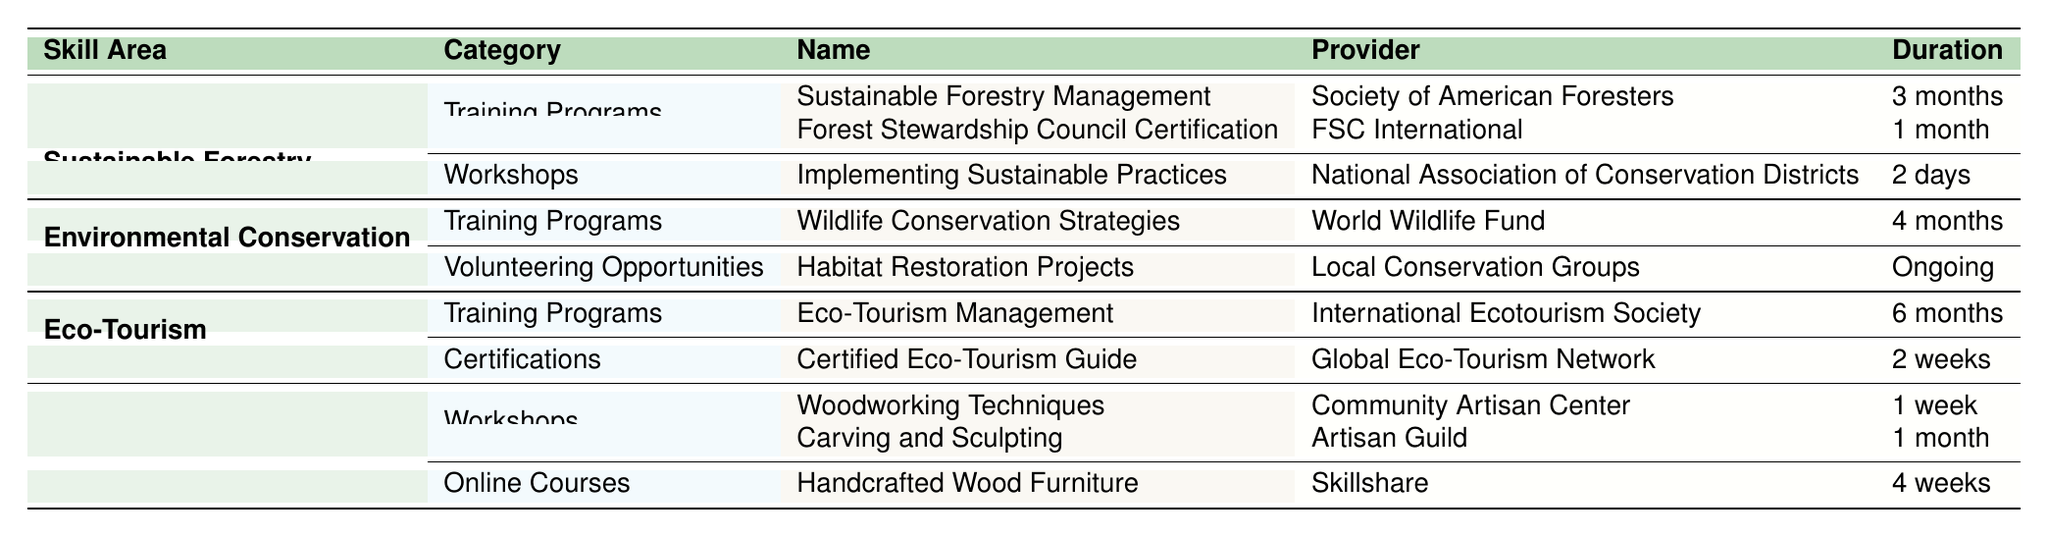What training program in Sustainable Forestry has the longest duration? The Sustainable Forestry Management program lasts for 3 months, while the Forest Stewardship Council Certification lasts for 1 month. Therefore, the longest duration is 3 months for the Sustainable Forestry Management program.
Answer: Sustainable Forestry Management How many workshops are listed under Crafts and Artisanal Skills? There are two workshops listed under Crafts and Artisanal Skills: "Woodworking Techniques" and "Carving and Sculpting." Thus, the total number of workshops is 2.
Answer: 2 Is there a volunteering opportunity listed in the Environmental Conservation section? Yes, the table includes "Habitat Restoration Projects" as a volunteering opportunity provided by Local Conservation Groups, confirming that such an opportunity exists.
Answer: Yes Which organization provides the Eco-Tourism Management training program? The training program for Eco-Tourism Management is provided by the International Ecotourism Society, as per the information in the table.
Answer: International Ecotourism Society What is the average duration of the training programs available across all skill areas? There are four training programs listed with durations of 3 months, 1 month, 4 months, and 6 months. Converting them to a common format (in months) gives: 3, 1, 4, and 6. The average is calculated as (3 + 1 + 4 + 6) / 4 = 14 / 4 = 3.5 months.
Answer: 3.5 months Are there any certification programs available in the Eco-Tourism category? Yes, there is a certification called "Certified Eco-Tourism Guide" provided by the Global Eco-Tourism Network, indicating the availability of certifications in this category.
Answer: Yes What is the shortest duration workshop listed in the table? The shortest duration workshop is "Implementing Sustainable Practices," which lasts for 2 days, while the rest are longer. Hence, the workshop with the shortest duration is this one.
Answer: 2 days Which skill area offers the most training programs? In the table, Sustainable Forestry includes 2 training programs, while Environmental Conservation has 1, Eco-Tourism has 1, and Crafts and Artisanal Skills has 1. Hence, Sustainable Forestry offers the most with 2 training programs.
Answer: Sustainable Forestry What is the total number of skill areas mentioned in the table? The table outlines four distinct skill areas: Sustainable Forestry, Environmental Conservation, Eco-Tourism, and Crafts and Artisanal Skills. Hence, the total number of skill areas is 4.
Answer: 4 